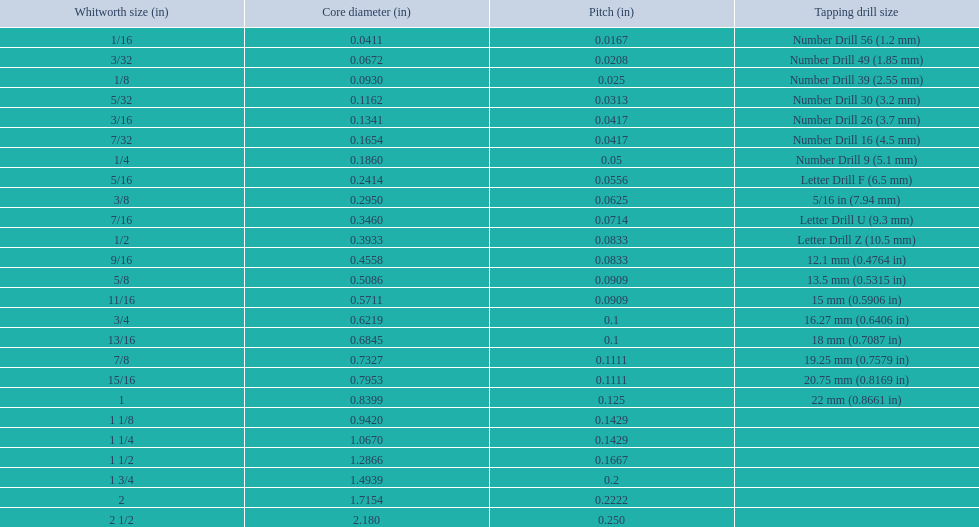What are all of the whitworth sizes? 1/16, 3/32, 1/8, 5/32, 3/16, 7/32, 1/4, 5/16, 3/8, 7/16, 1/2, 9/16, 5/8, 11/16, 3/4, 13/16, 7/8, 15/16, 1, 1 1/8, 1 1/4, 1 1/2, 1 3/4, 2, 2 1/2. How many threads per inch are in each size? 60, 48, 40, 32, 24, 24, 20, 18, 16, 14, 12, 12, 11, 11, 10, 10, 9, 9, 8, 7, 7, 6, 5, 4.5, 4. How many threads per inch are in the 3/16 size? 24. And which other size has the same number of threads? 7/32. 